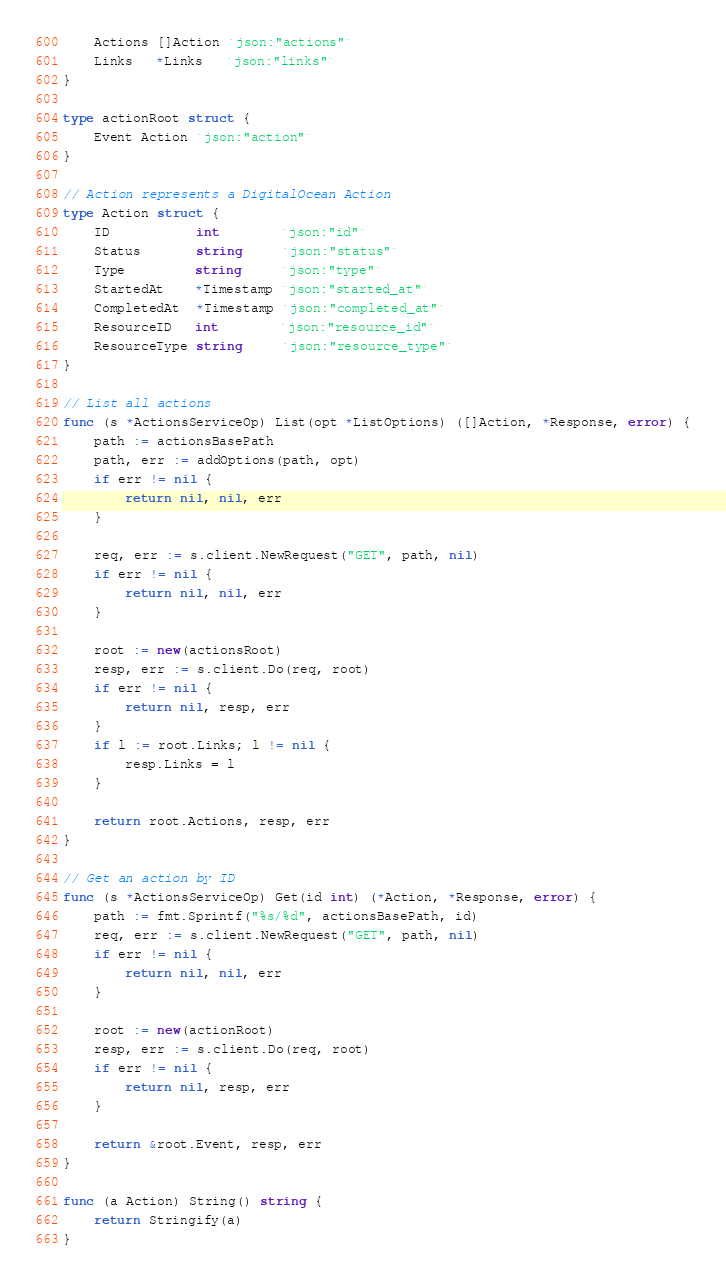<code> <loc_0><loc_0><loc_500><loc_500><_Go_>	Actions []Action `json:"actions"`
	Links   *Links   `json:"links"`
}

type actionRoot struct {
	Event Action `json:"action"`
}

// Action represents a DigitalOcean Action
type Action struct {
	ID           int        `json:"id"`
	Status       string     `json:"status"`
	Type         string     `json:"type"`
	StartedAt    *Timestamp `json:"started_at"`
	CompletedAt  *Timestamp `json:"completed_at"`
	ResourceID   int        `json:"resource_id"`
	ResourceType string     `json:"resource_type"`
}

// List all actions
func (s *ActionsServiceOp) List(opt *ListOptions) ([]Action, *Response, error) {
	path := actionsBasePath
	path, err := addOptions(path, opt)
	if err != nil {
		return nil, nil, err
	}

	req, err := s.client.NewRequest("GET", path, nil)
	if err != nil {
		return nil, nil, err
	}

	root := new(actionsRoot)
	resp, err := s.client.Do(req, root)
	if err != nil {
		return nil, resp, err
	}
	if l := root.Links; l != nil {
		resp.Links = l
	}

	return root.Actions, resp, err
}

// Get an action by ID
func (s *ActionsServiceOp) Get(id int) (*Action, *Response, error) {
	path := fmt.Sprintf("%s/%d", actionsBasePath, id)
	req, err := s.client.NewRequest("GET", path, nil)
	if err != nil {
		return nil, nil, err
	}

	root := new(actionRoot)
	resp, err := s.client.Do(req, root)
	if err != nil {
		return nil, resp, err
	}

	return &root.Event, resp, err
}

func (a Action) String() string {
	return Stringify(a)
}
</code> 